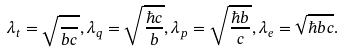Convert formula to latex. <formula><loc_0><loc_0><loc_500><loc_500>\lambda _ { t } = \sqrt { \frac { } { b c } } , \lambda _ { q } = \sqrt { \frac { \hbar { c } } { b } } , \lambda _ { p } = \sqrt { \frac { \hbar { b } } { c } } , \lambda _ { e } = \sqrt { \hbar { b } c } .</formula> 